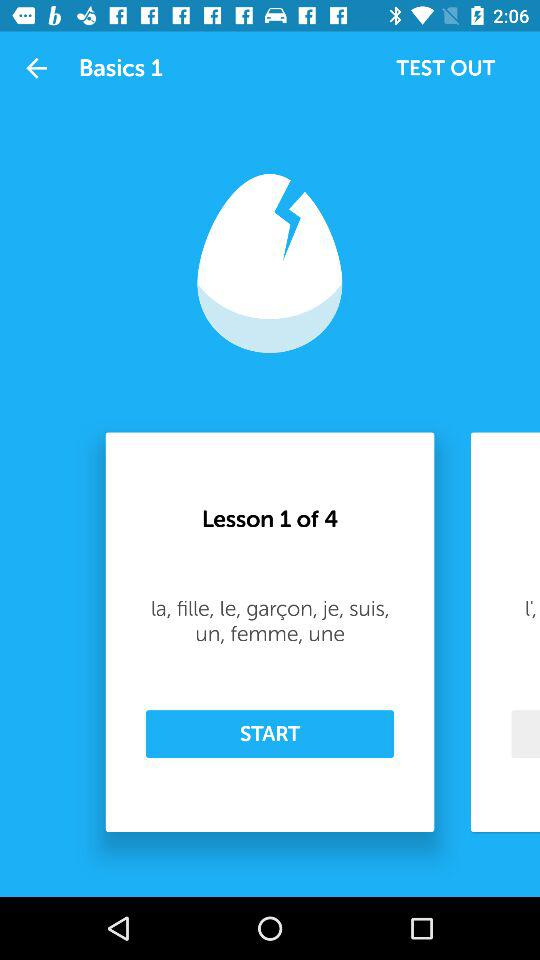What is "Basics" level? "Basics" level is 1. 